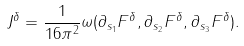Convert formula to latex. <formula><loc_0><loc_0><loc_500><loc_500>J ^ { \delta } & = \frac { 1 } { 1 6 \pi ^ { 2 } } \omega ( \partial _ { s _ { 1 } } F ^ { \delta } , \partial _ { s _ { 2 } } F ^ { \delta } , \partial _ { s _ { 3 } } F ^ { \delta } ) .</formula> 